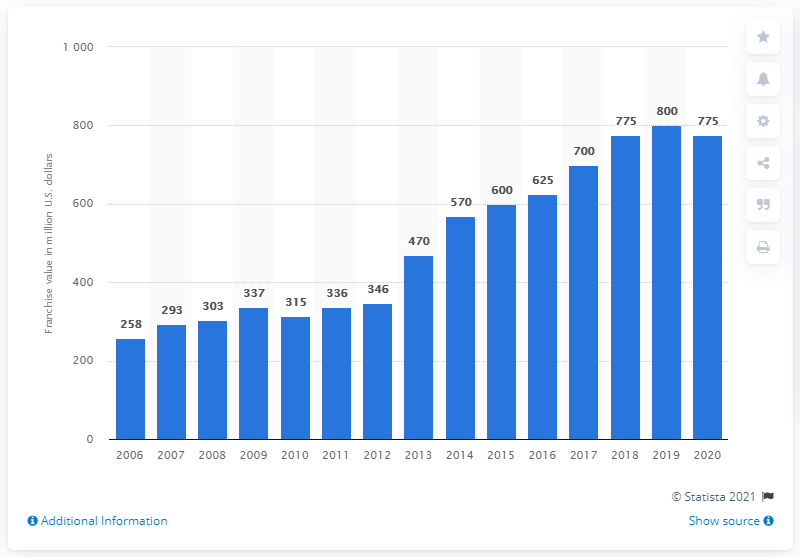Identify some key points in this picture. In 2020, the estimated value of the Detroit Red Wings was approximately 775 million dollars. 